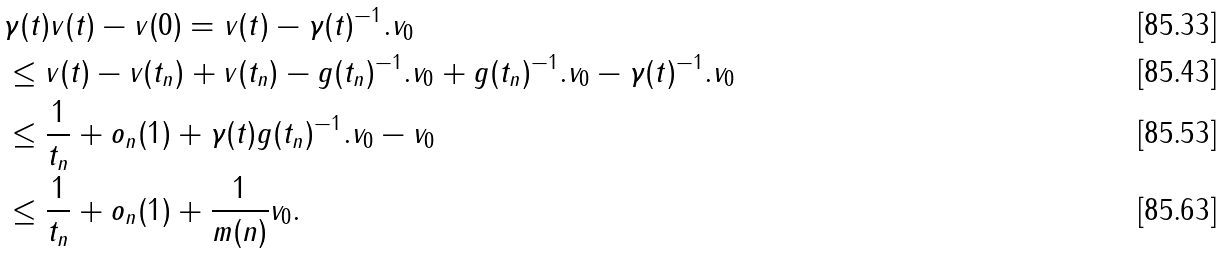<formula> <loc_0><loc_0><loc_500><loc_500>& \| \gamma ( t ) v ( t ) - v ( 0 ) \| = \| v ( t ) - \gamma ( t ) ^ { - 1 } . v _ { 0 } \| \\ & \leq \| v ( t ) - v ( t _ { n } ) \| + \| v ( t _ { n } ) - g ( t _ { n } ) ^ { - 1 } . v _ { 0 } \| + \| g ( t _ { n } ) ^ { - 1 } . v _ { 0 } - \gamma ( t ) ^ { - 1 } . v _ { 0 } \| \\ & \leq \frac { 1 } { t _ { n } } + o _ { n } ( 1 ) + \| \gamma ( t ) g ( t _ { n } ) ^ { - 1 } . v _ { 0 } - v _ { 0 } \| \\ & \leq \frac { 1 } { t _ { n } } + o _ { n } ( 1 ) + \frac { 1 } { m ( n ) } \| v _ { 0 } \| .</formula> 